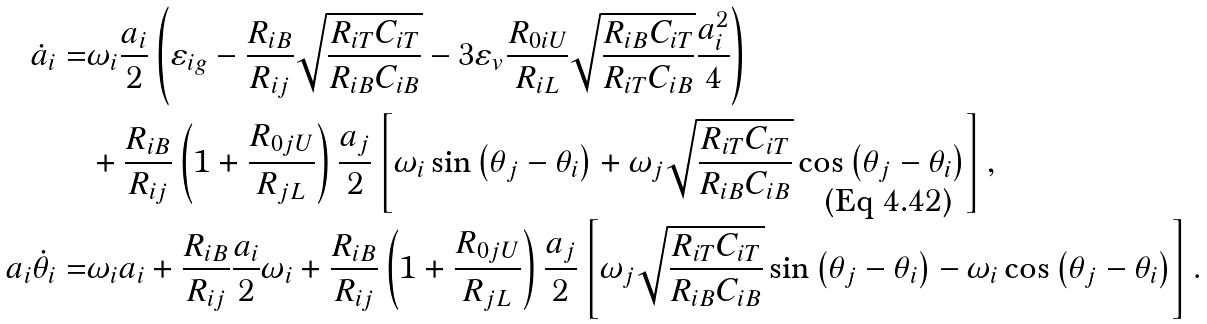Convert formula to latex. <formula><loc_0><loc_0><loc_500><loc_500>\dot { a } _ { i } = & \omega _ { i } \frac { a _ { i } } { 2 } \left ( \varepsilon _ { i g } - \frac { R _ { i B } } { R _ { i j } } \sqrt { \frac { R _ { i T } C _ { i T } } { R _ { i B } C _ { i B } } } - 3 \varepsilon _ { v } \frac { R _ { 0 i U } } { R _ { i L } } \sqrt { \frac { R _ { i B } C _ { i T } } { R _ { i T } C _ { i B } } } \frac { a _ { i } ^ { 2 } } { 4 } \right ) \\ & + \frac { R _ { i B } } { R _ { i j } } \left ( 1 + \frac { R _ { 0 j U } } { R _ { j L } } \right ) \frac { a _ { j } } { 2 } \left [ \omega _ { i } \sin \left ( \theta _ { j } - \theta _ { i } \right ) + \omega _ { j } \sqrt { \frac { R _ { i T } C _ { i T } } { R _ { i B } C _ { i B } } } \cos \left ( \theta _ { j } - \theta _ { i } \right ) \right ] , \\ a _ { i } \dot { \theta } _ { i } = & \omega _ { i } a _ { i } + \frac { R _ { i B } } { R _ { i j } } \frac { a _ { i } } { 2 } \omega _ { i } + \frac { R _ { i B } } { R _ { i j } } \left ( 1 + \frac { R _ { 0 j U } } { R _ { j L } } \right ) \frac { a _ { j } } { 2 } \left [ \omega _ { j } \sqrt { \frac { R _ { i T } C _ { i T } } { R _ { i B } C _ { i B } } } \sin \left ( \theta _ { j } - \theta _ { i } \right ) - \omega _ { i } \cos \left ( \theta _ { j } - \theta _ { i } \right ) \right ] .</formula> 